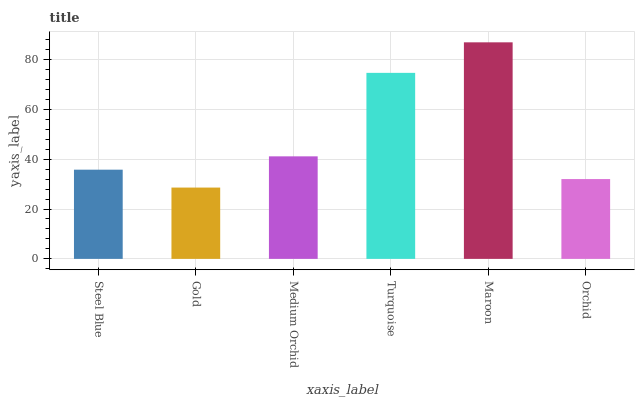Is Medium Orchid the minimum?
Answer yes or no. No. Is Medium Orchid the maximum?
Answer yes or no. No. Is Medium Orchid greater than Gold?
Answer yes or no. Yes. Is Gold less than Medium Orchid?
Answer yes or no. Yes. Is Gold greater than Medium Orchid?
Answer yes or no. No. Is Medium Orchid less than Gold?
Answer yes or no. No. Is Medium Orchid the high median?
Answer yes or no. Yes. Is Steel Blue the low median?
Answer yes or no. Yes. Is Turquoise the high median?
Answer yes or no. No. Is Orchid the low median?
Answer yes or no. No. 